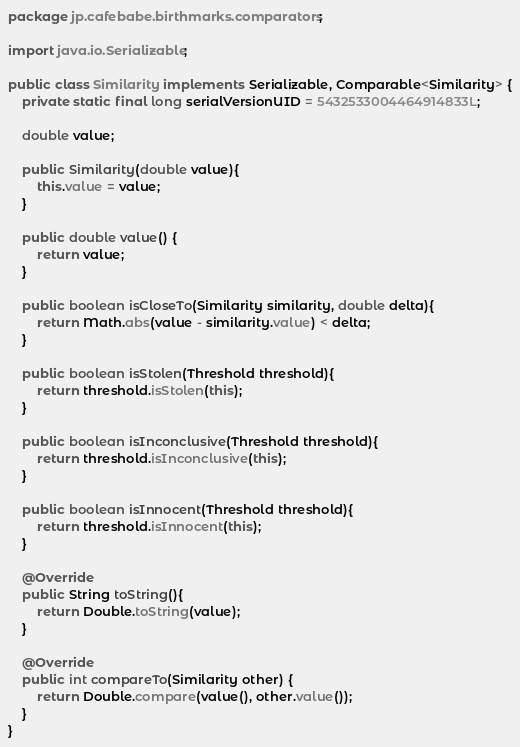<code> <loc_0><loc_0><loc_500><loc_500><_Java_>package jp.cafebabe.birthmarks.comparators;

import java.io.Serializable;

public class Similarity implements Serializable, Comparable<Similarity> {
    private static final long serialVersionUID = 5432533004464914833L;

    double value;

    public Similarity(double value){
        this.value = value;
    }

    public double value() {
        return value;
    }

    public boolean isCloseTo(Similarity similarity, double delta){
        return Math.abs(value - similarity.value) < delta;
    }

    public boolean isStolen(Threshold threshold){
        return threshold.isStolen(this);
    }

    public boolean isInconclusive(Threshold threshold){
        return threshold.isInconclusive(this);
    }

    public boolean isInnocent(Threshold threshold){
        return threshold.isInnocent(this);
    }

    @Override
    public String toString(){
        return Double.toString(value);
    }

    @Override
    public int compareTo(Similarity other) {
        return Double.compare(value(), other.value());
    }
}
</code> 